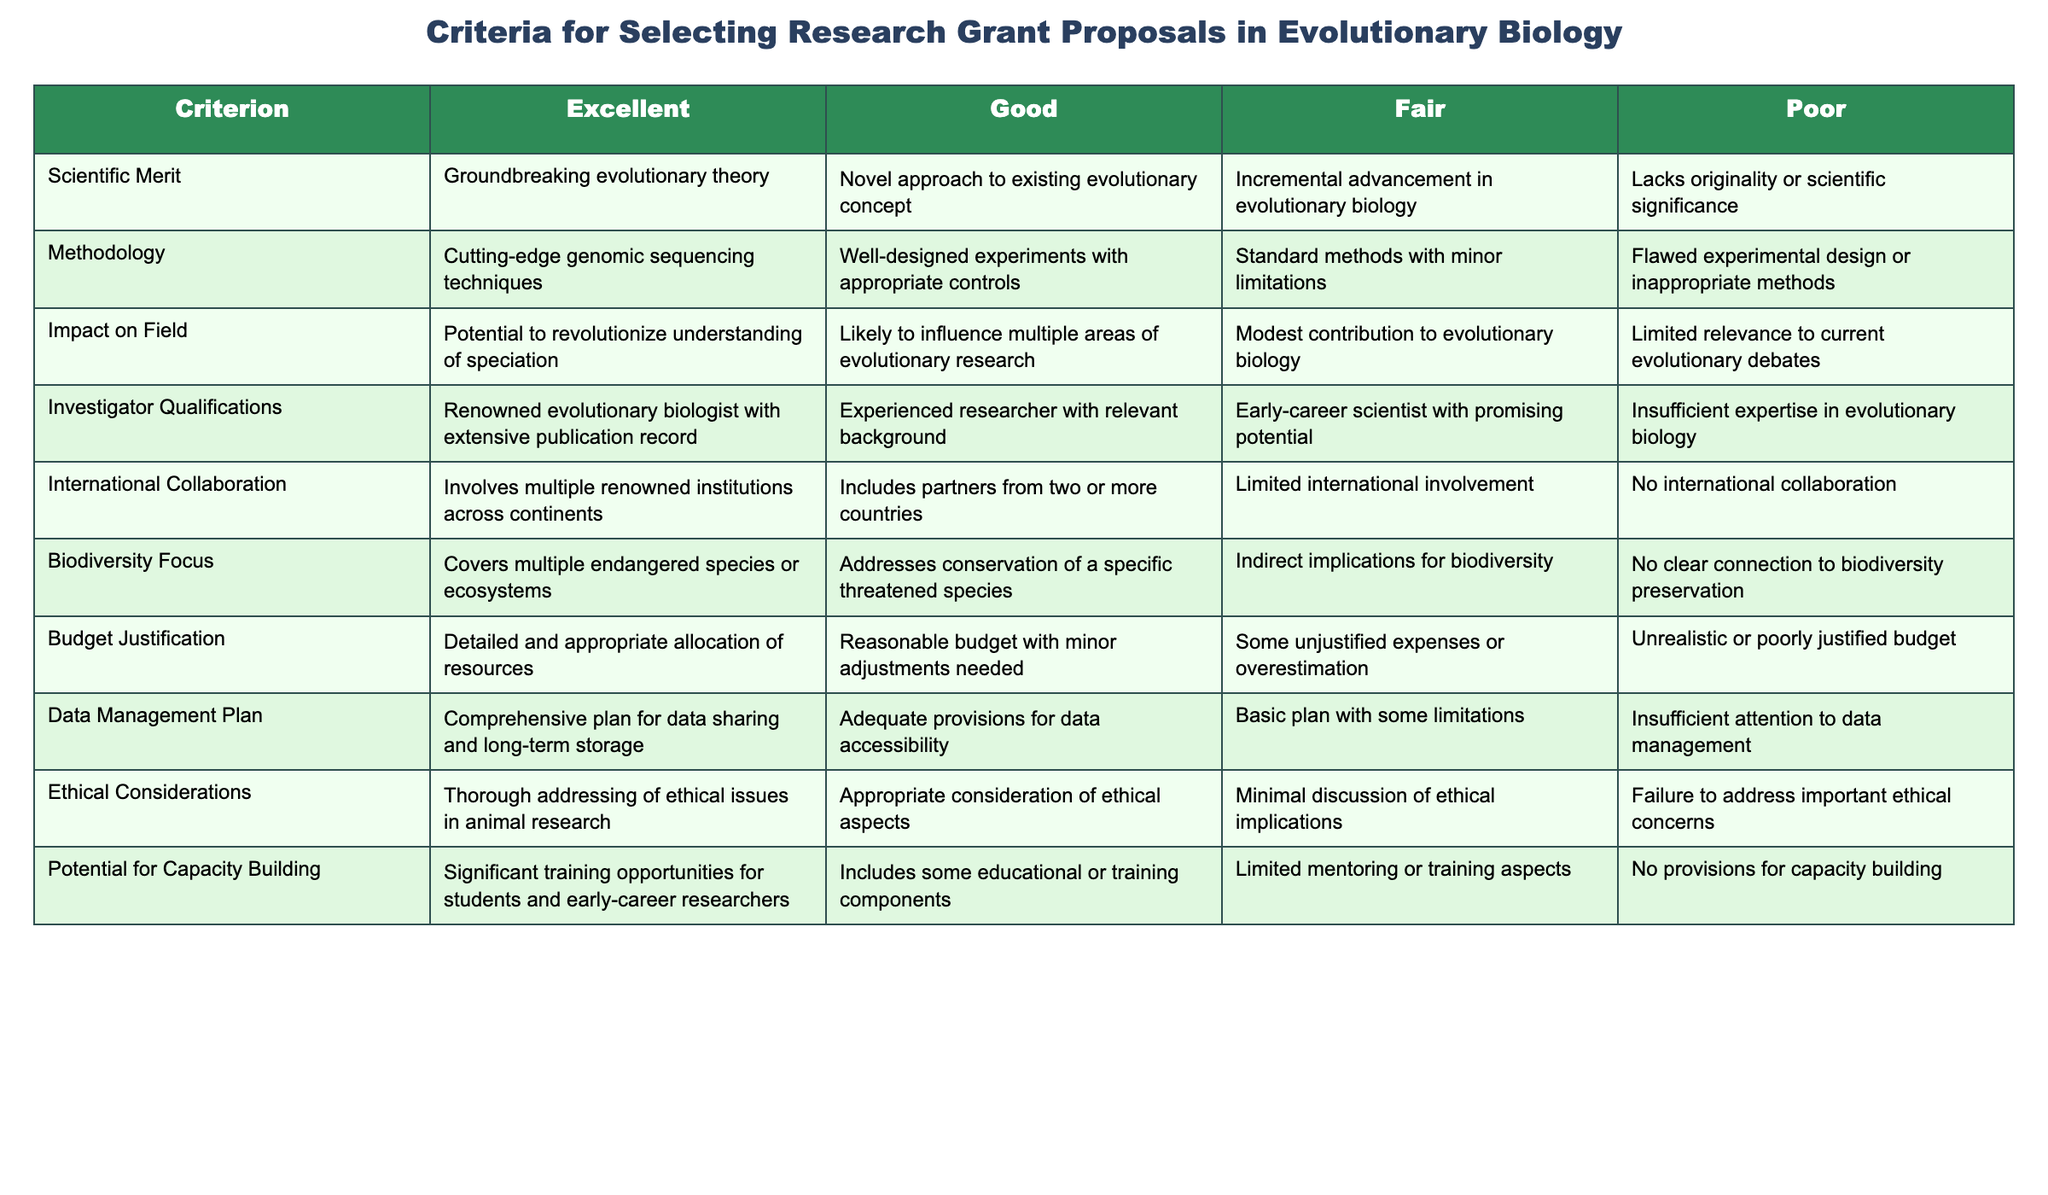What is the highest rating for Scientific Merit? According to the table, the highest rating for Scientific Merit is "Groundbreaking evolutionary theory." This is the value associated with the "Excellent" category for this criterion.
Answer: Groundbreaking evolutionary theory Which methodology rank is associated with minor limitations? The methodology rank associated with minor limitations is "Standard methods with minor limitations." This corresponds to the "Fair" category under the Methodology criterion.
Answer: Standard methods with minor limitations Is there any criterion where "Poor" category is mentioned? Yes, each criterion has a "Poor" category mentioned, indicating the lowest evaluation of that specific aspect in grant proposals.
Answer: Yes What are the possible impacts on the field categorized as "Excellent"? The possible impacts categorized as "Excellent" is "Potential to revolutionize understanding of speciation," which indicates significant importance and relevance to evolutionary research.
Answer: Potential to revolutionize understanding of speciation What is the difference in the focus on international collaboration between "Excellent" and "Fair"? "Excellent" focuses on involvement with multiple renowned institutions across continents, whereas "Fair" indicates limited international involvement. Thus, the difference is significant collaboration versus minimal collaboration.
Answer: Significant collaboration versus minimal collaboration How many criteria mention ethical considerations in their "Excellent" category? The table presents one criterion specifically for Ethical Considerations in the "Excellent" category, which is "Thorough addressing of ethical issues in animal research." It implies ethical concerns are given considerable importance in top-rated proposals.
Answer: One criterion Is there a criterion where the highest rated proposal impacts biodiversity? Yes, under Biodiversity Focus, the highest rating "Covers multiple endangered species or ecosystems" meets this criterion. It highlights the emphasis on conservation significant in this research area.
Answer: Yes What represents a significant training opportunity according to the criteria? According to the criteria, "significant training opportunities for students and early-career researchers" is classified under the "Excellent" category for Potential for Capacity Building, which emphasizes importance in mentoring.
Answer: Significant training opportunities for students and early-career researchers What is the overall significance of the Budget Justification for the "Excellent" category? The overall significance emphasizes the necessity of a "Detailed and appropriate allocation of resources," which is essential for successful grant proposals. Detailed budget justifications not only ensure that funds are used efficiently but also demonstrate careful planning and credibility to stakeholders.
Answer: Detailed and appropriate allocation of resources 